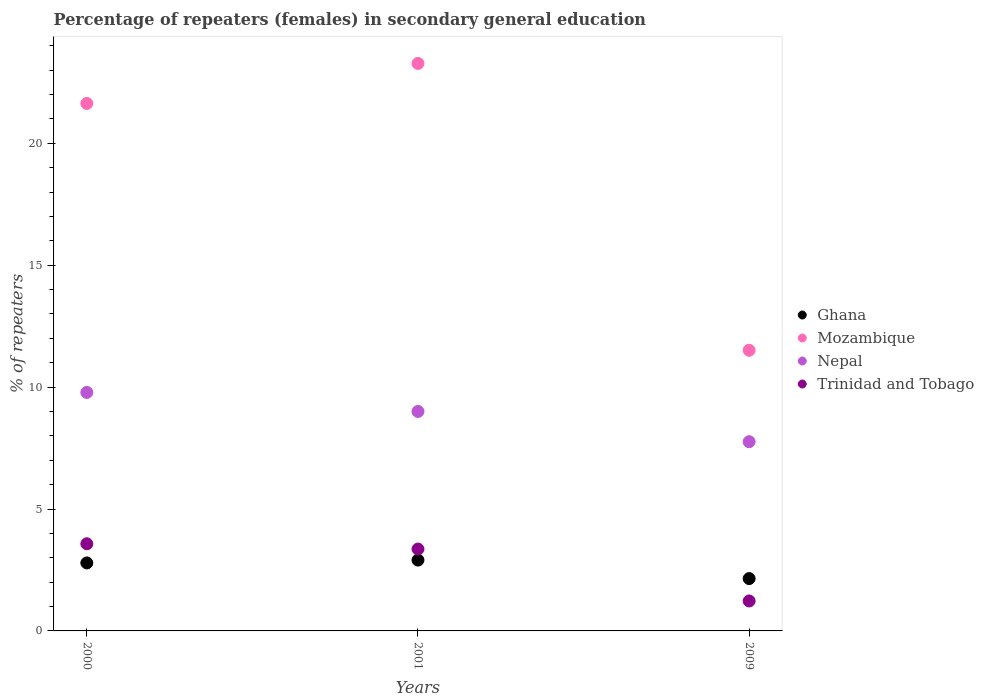Is the number of dotlines equal to the number of legend labels?
Your answer should be very brief. Yes. What is the percentage of female repeaters in Ghana in 2000?
Keep it short and to the point. 2.79. Across all years, what is the maximum percentage of female repeaters in Mozambique?
Keep it short and to the point. 23.28. Across all years, what is the minimum percentage of female repeaters in Nepal?
Ensure brevity in your answer.  7.76. In which year was the percentage of female repeaters in Ghana maximum?
Your response must be concise. 2001. What is the total percentage of female repeaters in Ghana in the graph?
Provide a succinct answer. 7.84. What is the difference between the percentage of female repeaters in Nepal in 2000 and that in 2009?
Ensure brevity in your answer.  2.02. What is the difference between the percentage of female repeaters in Ghana in 2000 and the percentage of female repeaters in Mozambique in 2009?
Make the answer very short. -8.72. What is the average percentage of female repeaters in Nepal per year?
Provide a succinct answer. 8.85. In the year 2000, what is the difference between the percentage of female repeaters in Nepal and percentage of female repeaters in Ghana?
Your response must be concise. 6.99. What is the ratio of the percentage of female repeaters in Mozambique in 2000 to that in 2001?
Make the answer very short. 0.93. Is the difference between the percentage of female repeaters in Nepal in 2000 and 2009 greater than the difference between the percentage of female repeaters in Ghana in 2000 and 2009?
Offer a terse response. Yes. What is the difference between the highest and the second highest percentage of female repeaters in Mozambique?
Provide a succinct answer. 1.64. What is the difference between the highest and the lowest percentage of female repeaters in Nepal?
Ensure brevity in your answer.  2.02. In how many years, is the percentage of female repeaters in Trinidad and Tobago greater than the average percentage of female repeaters in Trinidad and Tobago taken over all years?
Offer a terse response. 2. Is the sum of the percentage of female repeaters in Nepal in 2001 and 2009 greater than the maximum percentage of female repeaters in Ghana across all years?
Keep it short and to the point. Yes. Is it the case that in every year, the sum of the percentage of female repeaters in Nepal and percentage of female repeaters in Ghana  is greater than the sum of percentage of female repeaters in Mozambique and percentage of female repeaters in Trinidad and Tobago?
Offer a terse response. Yes. Is it the case that in every year, the sum of the percentage of female repeaters in Ghana and percentage of female repeaters in Mozambique  is greater than the percentage of female repeaters in Nepal?
Offer a terse response. Yes. How many dotlines are there?
Keep it short and to the point. 4. What is the difference between two consecutive major ticks on the Y-axis?
Your answer should be very brief. 5. Where does the legend appear in the graph?
Provide a succinct answer. Center right. How are the legend labels stacked?
Make the answer very short. Vertical. What is the title of the graph?
Provide a short and direct response. Percentage of repeaters (females) in secondary general education. What is the label or title of the X-axis?
Provide a short and direct response. Years. What is the label or title of the Y-axis?
Keep it short and to the point. % of repeaters. What is the % of repeaters in Ghana in 2000?
Make the answer very short. 2.79. What is the % of repeaters in Mozambique in 2000?
Your answer should be very brief. 21.63. What is the % of repeaters in Nepal in 2000?
Your answer should be very brief. 9.78. What is the % of repeaters in Trinidad and Tobago in 2000?
Keep it short and to the point. 3.57. What is the % of repeaters in Ghana in 2001?
Provide a succinct answer. 2.91. What is the % of repeaters in Mozambique in 2001?
Keep it short and to the point. 23.28. What is the % of repeaters in Nepal in 2001?
Offer a very short reply. 9. What is the % of repeaters of Trinidad and Tobago in 2001?
Your answer should be compact. 3.36. What is the % of repeaters of Ghana in 2009?
Provide a succinct answer. 2.15. What is the % of repeaters in Mozambique in 2009?
Your answer should be very brief. 11.51. What is the % of repeaters of Nepal in 2009?
Make the answer very short. 7.76. What is the % of repeaters in Trinidad and Tobago in 2009?
Provide a short and direct response. 1.23. Across all years, what is the maximum % of repeaters of Ghana?
Keep it short and to the point. 2.91. Across all years, what is the maximum % of repeaters of Mozambique?
Make the answer very short. 23.28. Across all years, what is the maximum % of repeaters of Nepal?
Your answer should be very brief. 9.78. Across all years, what is the maximum % of repeaters of Trinidad and Tobago?
Your answer should be compact. 3.57. Across all years, what is the minimum % of repeaters of Ghana?
Ensure brevity in your answer.  2.15. Across all years, what is the minimum % of repeaters in Mozambique?
Keep it short and to the point. 11.51. Across all years, what is the minimum % of repeaters of Nepal?
Your answer should be compact. 7.76. Across all years, what is the minimum % of repeaters of Trinidad and Tobago?
Make the answer very short. 1.23. What is the total % of repeaters of Ghana in the graph?
Offer a very short reply. 7.84. What is the total % of repeaters of Mozambique in the graph?
Provide a succinct answer. 56.42. What is the total % of repeaters in Nepal in the graph?
Offer a very short reply. 26.55. What is the total % of repeaters of Trinidad and Tobago in the graph?
Make the answer very short. 8.16. What is the difference between the % of repeaters of Ghana in 2000 and that in 2001?
Your answer should be compact. -0.12. What is the difference between the % of repeaters in Mozambique in 2000 and that in 2001?
Your answer should be compact. -1.64. What is the difference between the % of repeaters of Nepal in 2000 and that in 2001?
Your response must be concise. 0.78. What is the difference between the % of repeaters of Trinidad and Tobago in 2000 and that in 2001?
Give a very brief answer. 0.22. What is the difference between the % of repeaters in Ghana in 2000 and that in 2009?
Your answer should be very brief. 0.64. What is the difference between the % of repeaters of Mozambique in 2000 and that in 2009?
Your answer should be very brief. 10.12. What is the difference between the % of repeaters of Nepal in 2000 and that in 2009?
Provide a succinct answer. 2.02. What is the difference between the % of repeaters of Trinidad and Tobago in 2000 and that in 2009?
Make the answer very short. 2.35. What is the difference between the % of repeaters in Ghana in 2001 and that in 2009?
Give a very brief answer. 0.76. What is the difference between the % of repeaters of Mozambique in 2001 and that in 2009?
Your answer should be compact. 11.76. What is the difference between the % of repeaters of Nepal in 2001 and that in 2009?
Offer a very short reply. 1.24. What is the difference between the % of repeaters of Trinidad and Tobago in 2001 and that in 2009?
Ensure brevity in your answer.  2.13. What is the difference between the % of repeaters of Ghana in 2000 and the % of repeaters of Mozambique in 2001?
Your answer should be very brief. -20.49. What is the difference between the % of repeaters in Ghana in 2000 and the % of repeaters in Nepal in 2001?
Provide a short and direct response. -6.21. What is the difference between the % of repeaters of Ghana in 2000 and the % of repeaters of Trinidad and Tobago in 2001?
Give a very brief answer. -0.57. What is the difference between the % of repeaters of Mozambique in 2000 and the % of repeaters of Nepal in 2001?
Your response must be concise. 12.63. What is the difference between the % of repeaters in Mozambique in 2000 and the % of repeaters in Trinidad and Tobago in 2001?
Your answer should be compact. 18.28. What is the difference between the % of repeaters of Nepal in 2000 and the % of repeaters of Trinidad and Tobago in 2001?
Make the answer very short. 6.42. What is the difference between the % of repeaters in Ghana in 2000 and the % of repeaters in Mozambique in 2009?
Ensure brevity in your answer.  -8.72. What is the difference between the % of repeaters in Ghana in 2000 and the % of repeaters in Nepal in 2009?
Offer a terse response. -4.97. What is the difference between the % of repeaters of Ghana in 2000 and the % of repeaters of Trinidad and Tobago in 2009?
Ensure brevity in your answer.  1.56. What is the difference between the % of repeaters in Mozambique in 2000 and the % of repeaters in Nepal in 2009?
Offer a terse response. 13.87. What is the difference between the % of repeaters in Mozambique in 2000 and the % of repeaters in Trinidad and Tobago in 2009?
Offer a very short reply. 20.41. What is the difference between the % of repeaters of Nepal in 2000 and the % of repeaters of Trinidad and Tobago in 2009?
Offer a very short reply. 8.55. What is the difference between the % of repeaters in Ghana in 2001 and the % of repeaters in Mozambique in 2009?
Make the answer very short. -8.6. What is the difference between the % of repeaters of Ghana in 2001 and the % of repeaters of Nepal in 2009?
Offer a very short reply. -4.86. What is the difference between the % of repeaters of Ghana in 2001 and the % of repeaters of Trinidad and Tobago in 2009?
Ensure brevity in your answer.  1.68. What is the difference between the % of repeaters of Mozambique in 2001 and the % of repeaters of Nepal in 2009?
Offer a terse response. 15.51. What is the difference between the % of repeaters in Mozambique in 2001 and the % of repeaters in Trinidad and Tobago in 2009?
Make the answer very short. 22.05. What is the difference between the % of repeaters in Nepal in 2001 and the % of repeaters in Trinidad and Tobago in 2009?
Your response must be concise. 7.77. What is the average % of repeaters in Ghana per year?
Make the answer very short. 2.61. What is the average % of repeaters in Mozambique per year?
Your answer should be very brief. 18.81. What is the average % of repeaters in Nepal per year?
Offer a terse response. 8.85. What is the average % of repeaters in Trinidad and Tobago per year?
Your response must be concise. 2.72. In the year 2000, what is the difference between the % of repeaters of Ghana and % of repeaters of Mozambique?
Provide a succinct answer. -18.85. In the year 2000, what is the difference between the % of repeaters of Ghana and % of repeaters of Nepal?
Give a very brief answer. -6.99. In the year 2000, what is the difference between the % of repeaters in Ghana and % of repeaters in Trinidad and Tobago?
Provide a short and direct response. -0.79. In the year 2000, what is the difference between the % of repeaters of Mozambique and % of repeaters of Nepal?
Make the answer very short. 11.85. In the year 2000, what is the difference between the % of repeaters of Mozambique and % of repeaters of Trinidad and Tobago?
Ensure brevity in your answer.  18.06. In the year 2000, what is the difference between the % of repeaters of Nepal and % of repeaters of Trinidad and Tobago?
Your answer should be very brief. 6.21. In the year 2001, what is the difference between the % of repeaters of Ghana and % of repeaters of Mozambique?
Offer a very short reply. -20.37. In the year 2001, what is the difference between the % of repeaters of Ghana and % of repeaters of Nepal?
Make the answer very short. -6.1. In the year 2001, what is the difference between the % of repeaters in Ghana and % of repeaters in Trinidad and Tobago?
Offer a terse response. -0.45. In the year 2001, what is the difference between the % of repeaters in Mozambique and % of repeaters in Nepal?
Your response must be concise. 14.27. In the year 2001, what is the difference between the % of repeaters of Mozambique and % of repeaters of Trinidad and Tobago?
Make the answer very short. 19.92. In the year 2001, what is the difference between the % of repeaters of Nepal and % of repeaters of Trinidad and Tobago?
Make the answer very short. 5.64. In the year 2009, what is the difference between the % of repeaters in Ghana and % of repeaters in Mozambique?
Keep it short and to the point. -9.36. In the year 2009, what is the difference between the % of repeaters of Ghana and % of repeaters of Nepal?
Give a very brief answer. -5.61. In the year 2009, what is the difference between the % of repeaters in Ghana and % of repeaters in Trinidad and Tobago?
Your response must be concise. 0.92. In the year 2009, what is the difference between the % of repeaters in Mozambique and % of repeaters in Nepal?
Ensure brevity in your answer.  3.75. In the year 2009, what is the difference between the % of repeaters of Mozambique and % of repeaters of Trinidad and Tobago?
Keep it short and to the point. 10.28. In the year 2009, what is the difference between the % of repeaters of Nepal and % of repeaters of Trinidad and Tobago?
Your response must be concise. 6.53. What is the ratio of the % of repeaters of Ghana in 2000 to that in 2001?
Make the answer very short. 0.96. What is the ratio of the % of repeaters of Mozambique in 2000 to that in 2001?
Provide a succinct answer. 0.93. What is the ratio of the % of repeaters in Nepal in 2000 to that in 2001?
Your answer should be very brief. 1.09. What is the ratio of the % of repeaters in Trinidad and Tobago in 2000 to that in 2001?
Your answer should be very brief. 1.06. What is the ratio of the % of repeaters in Ghana in 2000 to that in 2009?
Make the answer very short. 1.3. What is the ratio of the % of repeaters of Mozambique in 2000 to that in 2009?
Provide a succinct answer. 1.88. What is the ratio of the % of repeaters in Nepal in 2000 to that in 2009?
Your response must be concise. 1.26. What is the ratio of the % of repeaters in Trinidad and Tobago in 2000 to that in 2009?
Offer a terse response. 2.91. What is the ratio of the % of repeaters of Ghana in 2001 to that in 2009?
Provide a succinct answer. 1.35. What is the ratio of the % of repeaters in Mozambique in 2001 to that in 2009?
Offer a very short reply. 2.02. What is the ratio of the % of repeaters in Nepal in 2001 to that in 2009?
Your answer should be compact. 1.16. What is the ratio of the % of repeaters in Trinidad and Tobago in 2001 to that in 2009?
Ensure brevity in your answer.  2.73. What is the difference between the highest and the second highest % of repeaters in Ghana?
Provide a short and direct response. 0.12. What is the difference between the highest and the second highest % of repeaters of Mozambique?
Your answer should be very brief. 1.64. What is the difference between the highest and the second highest % of repeaters in Nepal?
Your response must be concise. 0.78. What is the difference between the highest and the second highest % of repeaters in Trinidad and Tobago?
Your answer should be very brief. 0.22. What is the difference between the highest and the lowest % of repeaters of Ghana?
Ensure brevity in your answer.  0.76. What is the difference between the highest and the lowest % of repeaters in Mozambique?
Make the answer very short. 11.76. What is the difference between the highest and the lowest % of repeaters of Nepal?
Offer a terse response. 2.02. What is the difference between the highest and the lowest % of repeaters of Trinidad and Tobago?
Provide a short and direct response. 2.35. 